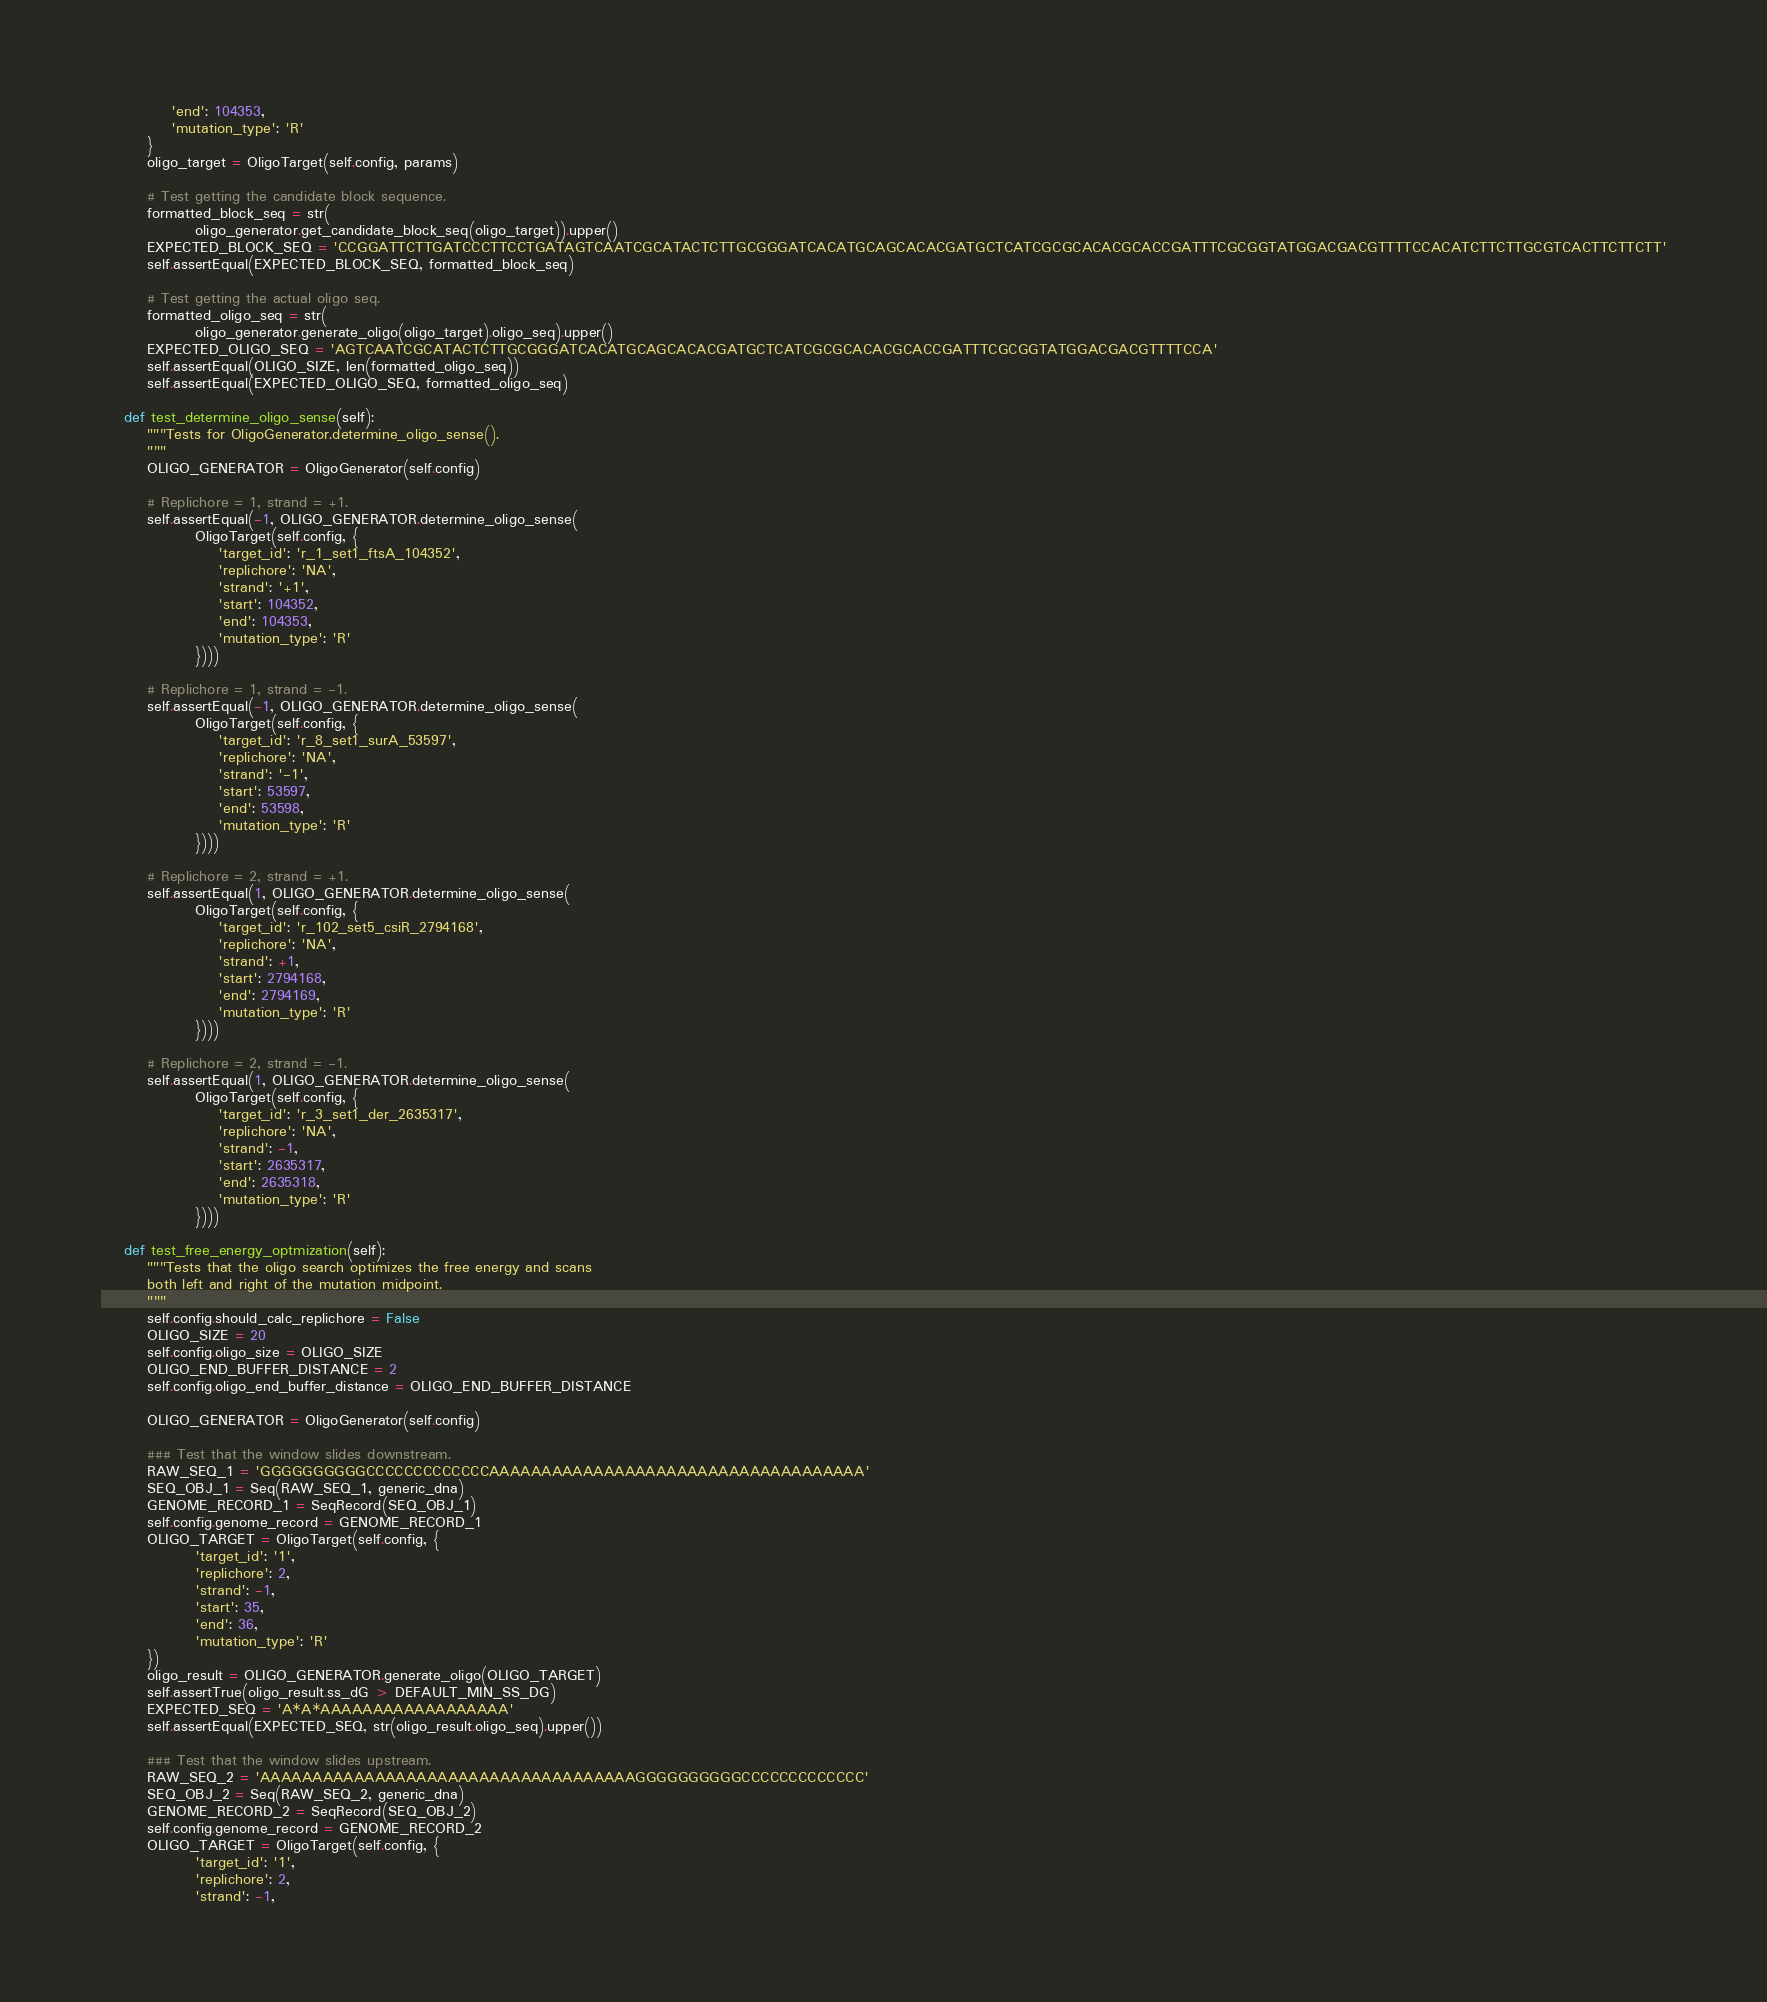<code> <loc_0><loc_0><loc_500><loc_500><_Python_>            'end': 104353,
            'mutation_type': 'R'
        }
        oligo_target = OligoTarget(self.config, params)

        # Test getting the candidate block sequence.
        formatted_block_seq = str(
                oligo_generator.get_candidate_block_seq(oligo_target)).upper()
        EXPECTED_BLOCK_SEQ = 'CCGGATTCTTGATCCCTTCCTGATAGTCAATCGCATACTCTTGCGGGATCACATGCAGCACACGATGCTCATCGCGCACACGCACCGATTTCGCGGTATGGACGACGTTTTCCACATCTTCTTGCGTCACTTCTTCTT'
        self.assertEqual(EXPECTED_BLOCK_SEQ, formatted_block_seq)

        # Test getting the actual oligo seq.
        formatted_oligo_seq = str(
                oligo_generator.generate_oligo(oligo_target).oligo_seq).upper()
        EXPECTED_OLIGO_SEQ = 'AGTCAATCGCATACTCTTGCGGGATCACATGCAGCACACGATGCTCATCGCGCACACGCACCGATTTCGCGGTATGGACGACGTTTTCCA'
        self.assertEqual(OLIGO_SIZE, len(formatted_oligo_seq))
        self.assertEqual(EXPECTED_OLIGO_SEQ, formatted_oligo_seq)

    def test_determine_oligo_sense(self):
        """Tests for OligoGenerator.determine_oligo_sense().
        """
        OLIGO_GENERATOR = OligoGenerator(self.config)

        # Replichore = 1, strand = +1.
        self.assertEqual(-1, OLIGO_GENERATOR.determine_oligo_sense(
                OligoTarget(self.config, {
                    'target_id': 'r_1_set1_ftsA_104352',
                    'replichore': 'NA',
                    'strand': '+1',
                    'start': 104352,
                    'end': 104353,
                    'mutation_type': 'R'
                })))

        # Replichore = 1, strand = -1.
        self.assertEqual(-1, OLIGO_GENERATOR.determine_oligo_sense(
                OligoTarget(self.config, {
                    'target_id': 'r_8_set1_surA_53597',
                    'replichore': 'NA',
                    'strand': '-1',
                    'start': 53597,
                    'end': 53598,
                    'mutation_type': 'R'
                })))

        # Replichore = 2, strand = +1.
        self.assertEqual(1, OLIGO_GENERATOR.determine_oligo_sense(
                OligoTarget(self.config, {
                    'target_id': 'r_102_set5_csiR_2794168',
                    'replichore': 'NA',
                    'strand': +1,
                    'start': 2794168,
                    'end': 2794169,
                    'mutation_type': 'R'
                })))

        # Replichore = 2, strand = -1.
        self.assertEqual(1, OLIGO_GENERATOR.determine_oligo_sense(
                OligoTarget(self.config, {
                    'target_id': 'r_3_set1_der_2635317',
                    'replichore': 'NA',
                    'strand': -1,
                    'start': 2635317,
                    'end': 2635318,
                    'mutation_type': 'R'
                })))

    def test_free_energy_optmization(self):
        """Tests that the oligo search optimizes the free energy and scans
        both left and right of the mutation midpoint.
        """
        self.config.should_calc_replichore = False
        OLIGO_SIZE = 20
        self.config.oligo_size = OLIGO_SIZE
        OLIGO_END_BUFFER_DISTANCE = 2
        self.config.oligo_end_buffer_distance = OLIGO_END_BUFFER_DISTANCE

        OLIGO_GENERATOR = OligoGenerator(self.config)

        ### Test that the window slides downstream.
        RAW_SEQ_1 = 'GGGGGGGGGGCCCCCCCCCCCCCAAAAAAAAAAAAAAAAAAAAAAAAAAAAAAAAAAAA'
        SEQ_OBJ_1 = Seq(RAW_SEQ_1, generic_dna)
        GENOME_RECORD_1 = SeqRecord(SEQ_OBJ_1)
        self.config.genome_record = GENOME_RECORD_1
        OLIGO_TARGET = OligoTarget(self.config, {
                'target_id': '1',
                'replichore': 2,
                'strand': -1,
                'start': 35,
                'end': 36,
                'mutation_type': 'R'
        })
        oligo_result = OLIGO_GENERATOR.generate_oligo(OLIGO_TARGET)
        self.assertTrue(oligo_result.ss_dG > DEFAULT_MIN_SS_DG)
        EXPECTED_SEQ = 'A*A*AAAAAAAAAAAAAAAAAA'
        self.assertEqual(EXPECTED_SEQ, str(oligo_result.oligo_seq).upper())

        ### Test that the window slides upstream.
        RAW_SEQ_2 = 'AAAAAAAAAAAAAAAAAAAAAAAAAAAAAAAAAAAAGGGGGGGGGGCCCCCCCCCCCCC'
        SEQ_OBJ_2 = Seq(RAW_SEQ_2, generic_dna)
        GENOME_RECORD_2 = SeqRecord(SEQ_OBJ_2)
        self.config.genome_record = GENOME_RECORD_2
        OLIGO_TARGET = OligoTarget(self.config, {
                'target_id': '1',
                'replichore': 2,
                'strand': -1,</code> 